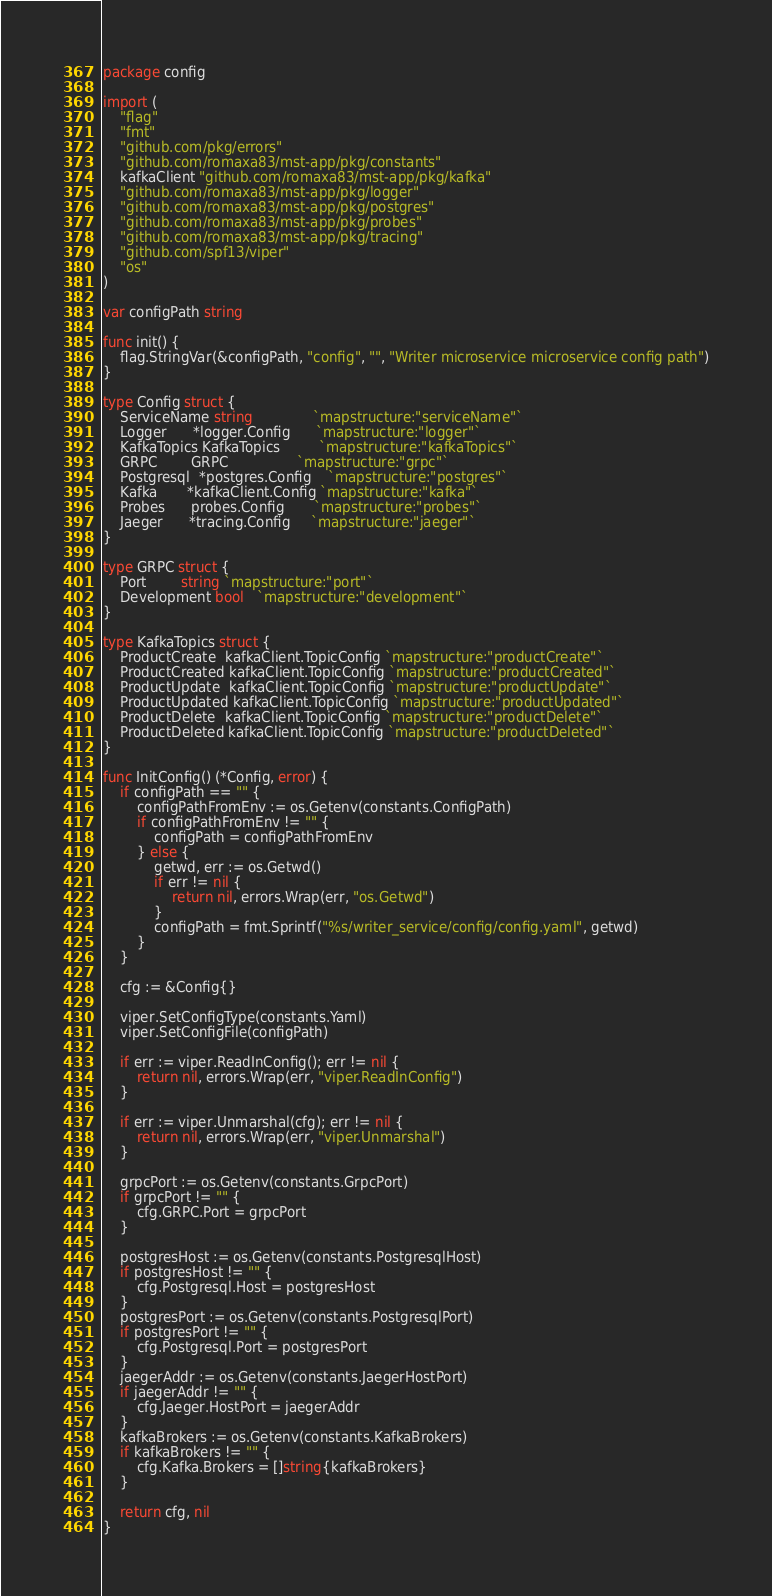<code> <loc_0><loc_0><loc_500><loc_500><_Go_>package config

import (
	"flag"
	"fmt"
	"github.com/pkg/errors"
	"github.com/romaxa83/mst-app/pkg/constants"
	kafkaClient "github.com/romaxa83/mst-app/pkg/kafka"
	"github.com/romaxa83/mst-app/pkg/logger"
	"github.com/romaxa83/mst-app/pkg/postgres"
	"github.com/romaxa83/mst-app/pkg/probes"
	"github.com/romaxa83/mst-app/pkg/tracing"
	"github.com/spf13/viper"
	"os"
)

var configPath string

func init() {
	flag.StringVar(&configPath, "config", "", "Writer microservice microservice config path")
}

type Config struct {
	ServiceName string              `mapstructure:"serviceName"`
	Logger      *logger.Config      `mapstructure:"logger"`
	KafkaTopics KafkaTopics         `mapstructure:"kafkaTopics"`
	GRPC        GRPC                `mapstructure:"grpc"`
	Postgresql  *postgres.Config    `mapstructure:"postgres"`
	Kafka       *kafkaClient.Config `mapstructure:"kafka"`
	Probes      probes.Config       `mapstructure:"probes"`
	Jaeger      *tracing.Config     `mapstructure:"jaeger"`
}

type GRPC struct {
	Port        string `mapstructure:"port"`
	Development bool   `mapstructure:"development"`
}

type KafkaTopics struct {
	ProductCreate  kafkaClient.TopicConfig `mapstructure:"productCreate"`
	ProductCreated kafkaClient.TopicConfig `mapstructure:"productCreated"`
	ProductUpdate  kafkaClient.TopicConfig `mapstructure:"productUpdate"`
	ProductUpdated kafkaClient.TopicConfig `mapstructure:"productUpdated"`
	ProductDelete  kafkaClient.TopicConfig `mapstructure:"productDelete"`
	ProductDeleted kafkaClient.TopicConfig `mapstructure:"productDeleted"`
}

func InitConfig() (*Config, error) {
	if configPath == "" {
		configPathFromEnv := os.Getenv(constants.ConfigPath)
		if configPathFromEnv != "" {
			configPath = configPathFromEnv
		} else {
			getwd, err := os.Getwd()
			if err != nil {
				return nil, errors.Wrap(err, "os.Getwd")
			}
			configPath = fmt.Sprintf("%s/writer_service/config/config.yaml", getwd)
		}
	}

	cfg := &Config{}

	viper.SetConfigType(constants.Yaml)
	viper.SetConfigFile(configPath)

	if err := viper.ReadInConfig(); err != nil {
		return nil, errors.Wrap(err, "viper.ReadInConfig")
	}

	if err := viper.Unmarshal(cfg); err != nil {
		return nil, errors.Wrap(err, "viper.Unmarshal")
	}

	grpcPort := os.Getenv(constants.GrpcPort)
	if grpcPort != "" {
		cfg.GRPC.Port = grpcPort
	}

	postgresHost := os.Getenv(constants.PostgresqlHost)
	if postgresHost != "" {
		cfg.Postgresql.Host = postgresHost
	}
	postgresPort := os.Getenv(constants.PostgresqlPort)
	if postgresPort != "" {
		cfg.Postgresql.Port = postgresPort
	}
	jaegerAddr := os.Getenv(constants.JaegerHostPort)
	if jaegerAddr != "" {
		cfg.Jaeger.HostPort = jaegerAddr
	}
	kafkaBrokers := os.Getenv(constants.KafkaBrokers)
	if kafkaBrokers != "" {
		cfg.Kafka.Brokers = []string{kafkaBrokers}
	}

	return cfg, nil
}
</code> 